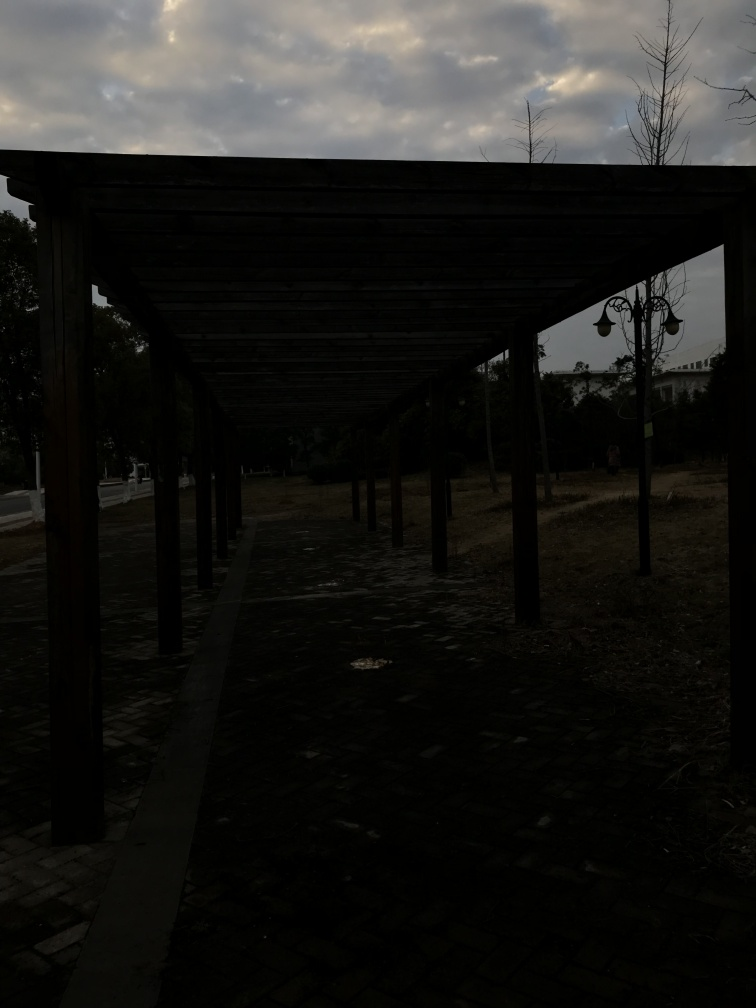What atmosphere does the image evoke? The picture exudes a serene and somewhat contemplative atmosphere, possibly due to the interplay of shadow and light along the pathway and the absence of any people, which also adds a hint of loneliness or stillness. 